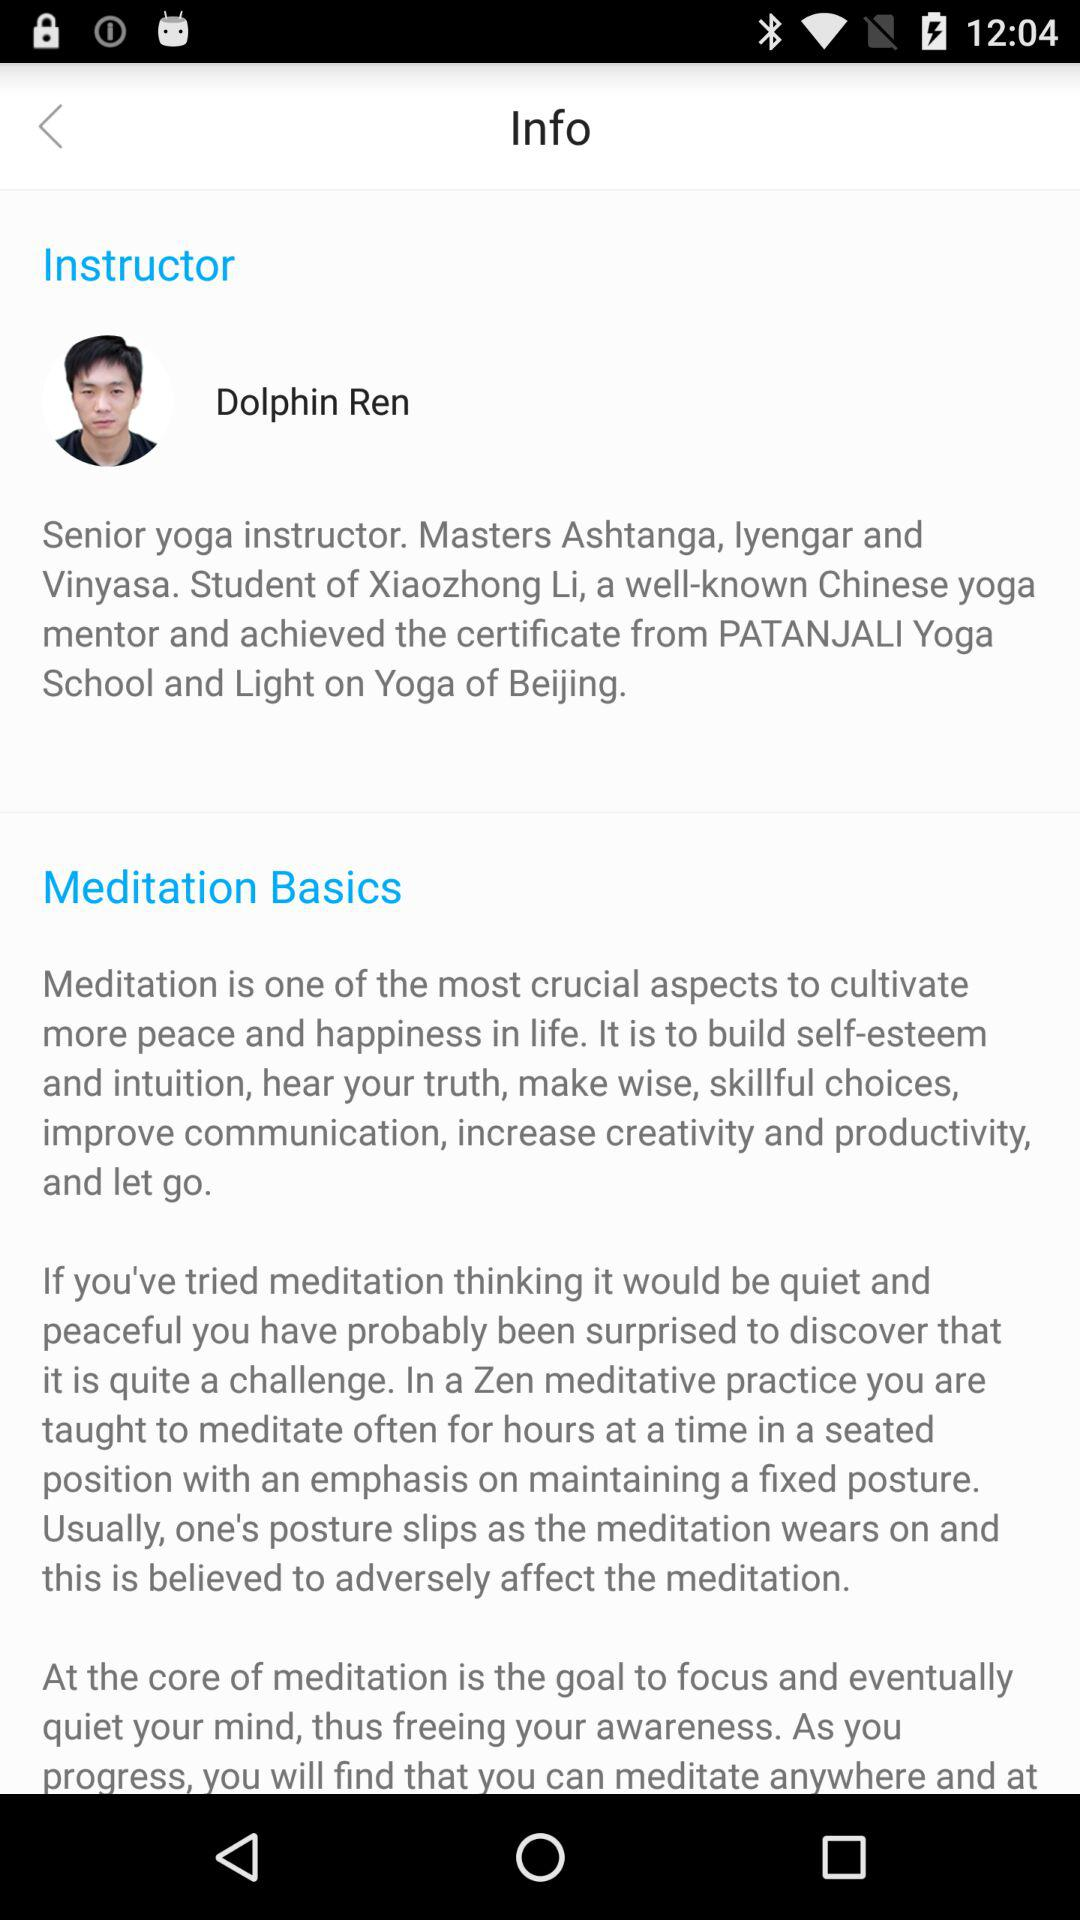What is the name of the yoga instructor? The name of the yoga instructor is Dolphin Ren. 